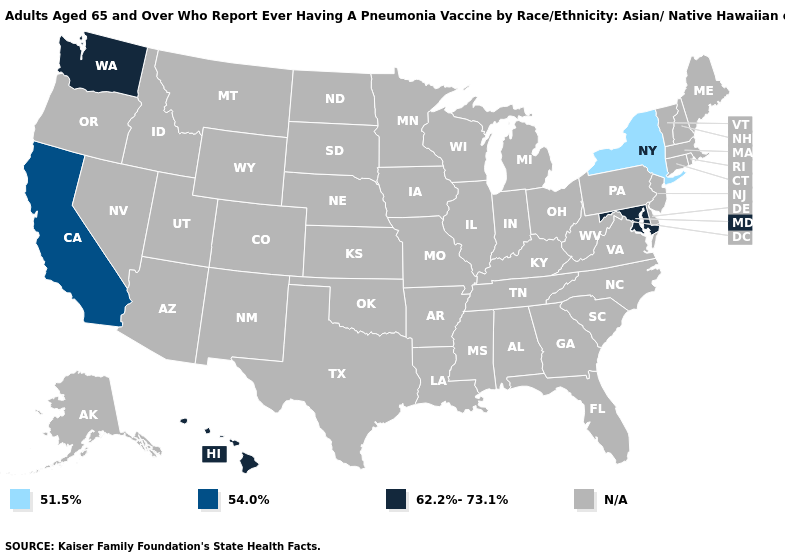Which states have the lowest value in the USA?
Quick response, please. New York. Is the legend a continuous bar?
Answer briefly. No. What is the value of Oklahoma?
Give a very brief answer. N/A. What is the value of Maryland?
Concise answer only. 62.2%-73.1%. What is the value of Texas?
Concise answer only. N/A. Does California have the lowest value in the West?
Be succinct. Yes. What is the value of Iowa?
Concise answer only. N/A. Does Hawaii have the lowest value in the USA?
Write a very short answer. No. 